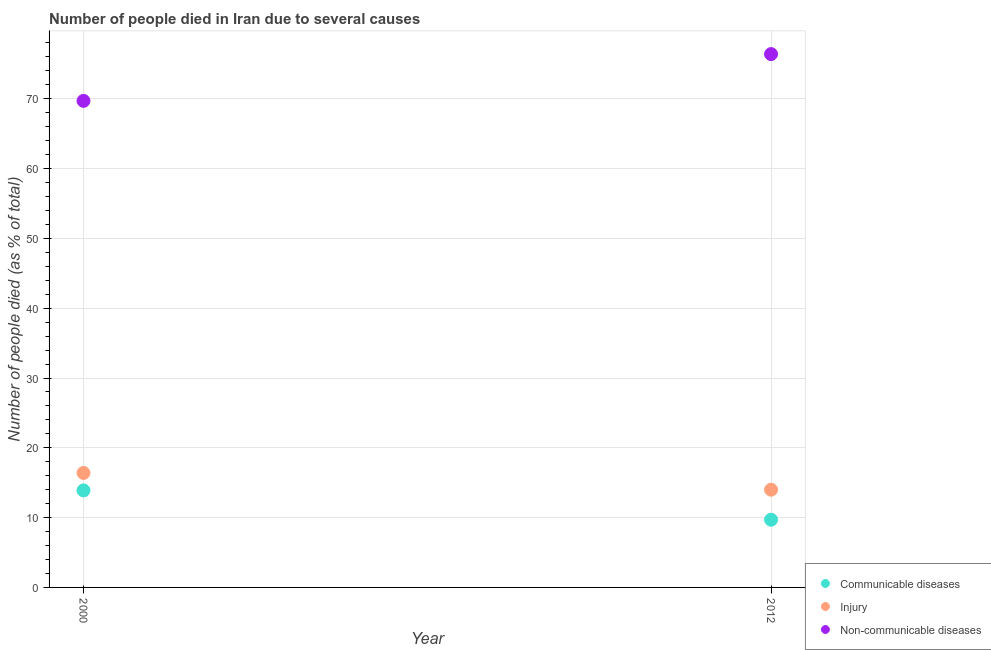Is the number of dotlines equal to the number of legend labels?
Provide a short and direct response. Yes. Across all years, what is the maximum number of people who dies of non-communicable diseases?
Offer a terse response. 76.4. Across all years, what is the minimum number of people who died of communicable diseases?
Offer a terse response. 9.7. What is the total number of people who dies of non-communicable diseases in the graph?
Offer a very short reply. 146.1. What is the difference between the number of people who died of injury in 2000 and that in 2012?
Your answer should be very brief. 2.4. What is the difference between the number of people who died of injury in 2012 and the number of people who dies of non-communicable diseases in 2000?
Your response must be concise. -55.7. What is the average number of people who died of communicable diseases per year?
Offer a very short reply. 11.8. In the year 2012, what is the difference between the number of people who died of injury and number of people who dies of non-communicable diseases?
Provide a short and direct response. -62.4. In how many years, is the number of people who died of injury greater than 54 %?
Provide a succinct answer. 0. What is the ratio of the number of people who dies of non-communicable diseases in 2000 to that in 2012?
Ensure brevity in your answer.  0.91. Is the number of people who died of injury in 2000 less than that in 2012?
Your response must be concise. No. In how many years, is the number of people who dies of non-communicable diseases greater than the average number of people who dies of non-communicable diseases taken over all years?
Keep it short and to the point. 1. Is it the case that in every year, the sum of the number of people who died of communicable diseases and number of people who died of injury is greater than the number of people who dies of non-communicable diseases?
Provide a short and direct response. No. Does the number of people who dies of non-communicable diseases monotonically increase over the years?
Your answer should be compact. Yes. Is the number of people who dies of non-communicable diseases strictly greater than the number of people who died of communicable diseases over the years?
Offer a very short reply. Yes. Is the number of people who died of injury strictly less than the number of people who died of communicable diseases over the years?
Your answer should be very brief. No. How many dotlines are there?
Your answer should be very brief. 3. How many years are there in the graph?
Offer a terse response. 2. Are the values on the major ticks of Y-axis written in scientific E-notation?
Make the answer very short. No. Does the graph contain any zero values?
Your answer should be very brief. No. Does the graph contain grids?
Offer a terse response. Yes. What is the title of the graph?
Keep it short and to the point. Number of people died in Iran due to several causes. Does "Coal" appear as one of the legend labels in the graph?
Keep it short and to the point. No. What is the label or title of the X-axis?
Make the answer very short. Year. What is the label or title of the Y-axis?
Provide a succinct answer. Number of people died (as % of total). What is the Number of people died (as % of total) of Non-communicable diseases in 2000?
Make the answer very short. 69.7. What is the Number of people died (as % of total) in Communicable diseases in 2012?
Give a very brief answer. 9.7. What is the Number of people died (as % of total) in Injury in 2012?
Your answer should be very brief. 14. What is the Number of people died (as % of total) in Non-communicable diseases in 2012?
Offer a terse response. 76.4. Across all years, what is the maximum Number of people died (as % of total) of Communicable diseases?
Your answer should be very brief. 13.9. Across all years, what is the maximum Number of people died (as % of total) in Injury?
Ensure brevity in your answer.  16.4. Across all years, what is the maximum Number of people died (as % of total) in Non-communicable diseases?
Give a very brief answer. 76.4. Across all years, what is the minimum Number of people died (as % of total) in Injury?
Offer a very short reply. 14. Across all years, what is the minimum Number of people died (as % of total) in Non-communicable diseases?
Give a very brief answer. 69.7. What is the total Number of people died (as % of total) of Communicable diseases in the graph?
Your answer should be compact. 23.6. What is the total Number of people died (as % of total) of Injury in the graph?
Ensure brevity in your answer.  30.4. What is the total Number of people died (as % of total) of Non-communicable diseases in the graph?
Offer a terse response. 146.1. What is the difference between the Number of people died (as % of total) of Non-communicable diseases in 2000 and that in 2012?
Provide a succinct answer. -6.7. What is the difference between the Number of people died (as % of total) of Communicable diseases in 2000 and the Number of people died (as % of total) of Non-communicable diseases in 2012?
Offer a terse response. -62.5. What is the difference between the Number of people died (as % of total) of Injury in 2000 and the Number of people died (as % of total) of Non-communicable diseases in 2012?
Make the answer very short. -60. What is the average Number of people died (as % of total) in Non-communicable diseases per year?
Keep it short and to the point. 73.05. In the year 2000, what is the difference between the Number of people died (as % of total) in Communicable diseases and Number of people died (as % of total) in Non-communicable diseases?
Offer a terse response. -55.8. In the year 2000, what is the difference between the Number of people died (as % of total) of Injury and Number of people died (as % of total) of Non-communicable diseases?
Your response must be concise. -53.3. In the year 2012, what is the difference between the Number of people died (as % of total) in Communicable diseases and Number of people died (as % of total) in Injury?
Ensure brevity in your answer.  -4.3. In the year 2012, what is the difference between the Number of people died (as % of total) of Communicable diseases and Number of people died (as % of total) of Non-communicable diseases?
Provide a short and direct response. -66.7. In the year 2012, what is the difference between the Number of people died (as % of total) of Injury and Number of people died (as % of total) of Non-communicable diseases?
Ensure brevity in your answer.  -62.4. What is the ratio of the Number of people died (as % of total) of Communicable diseases in 2000 to that in 2012?
Ensure brevity in your answer.  1.43. What is the ratio of the Number of people died (as % of total) of Injury in 2000 to that in 2012?
Your answer should be very brief. 1.17. What is the ratio of the Number of people died (as % of total) in Non-communicable diseases in 2000 to that in 2012?
Your answer should be compact. 0.91. What is the difference between the highest and the second highest Number of people died (as % of total) in Non-communicable diseases?
Give a very brief answer. 6.7. What is the difference between the highest and the lowest Number of people died (as % of total) of Communicable diseases?
Offer a very short reply. 4.2. What is the difference between the highest and the lowest Number of people died (as % of total) of Non-communicable diseases?
Offer a very short reply. 6.7. 